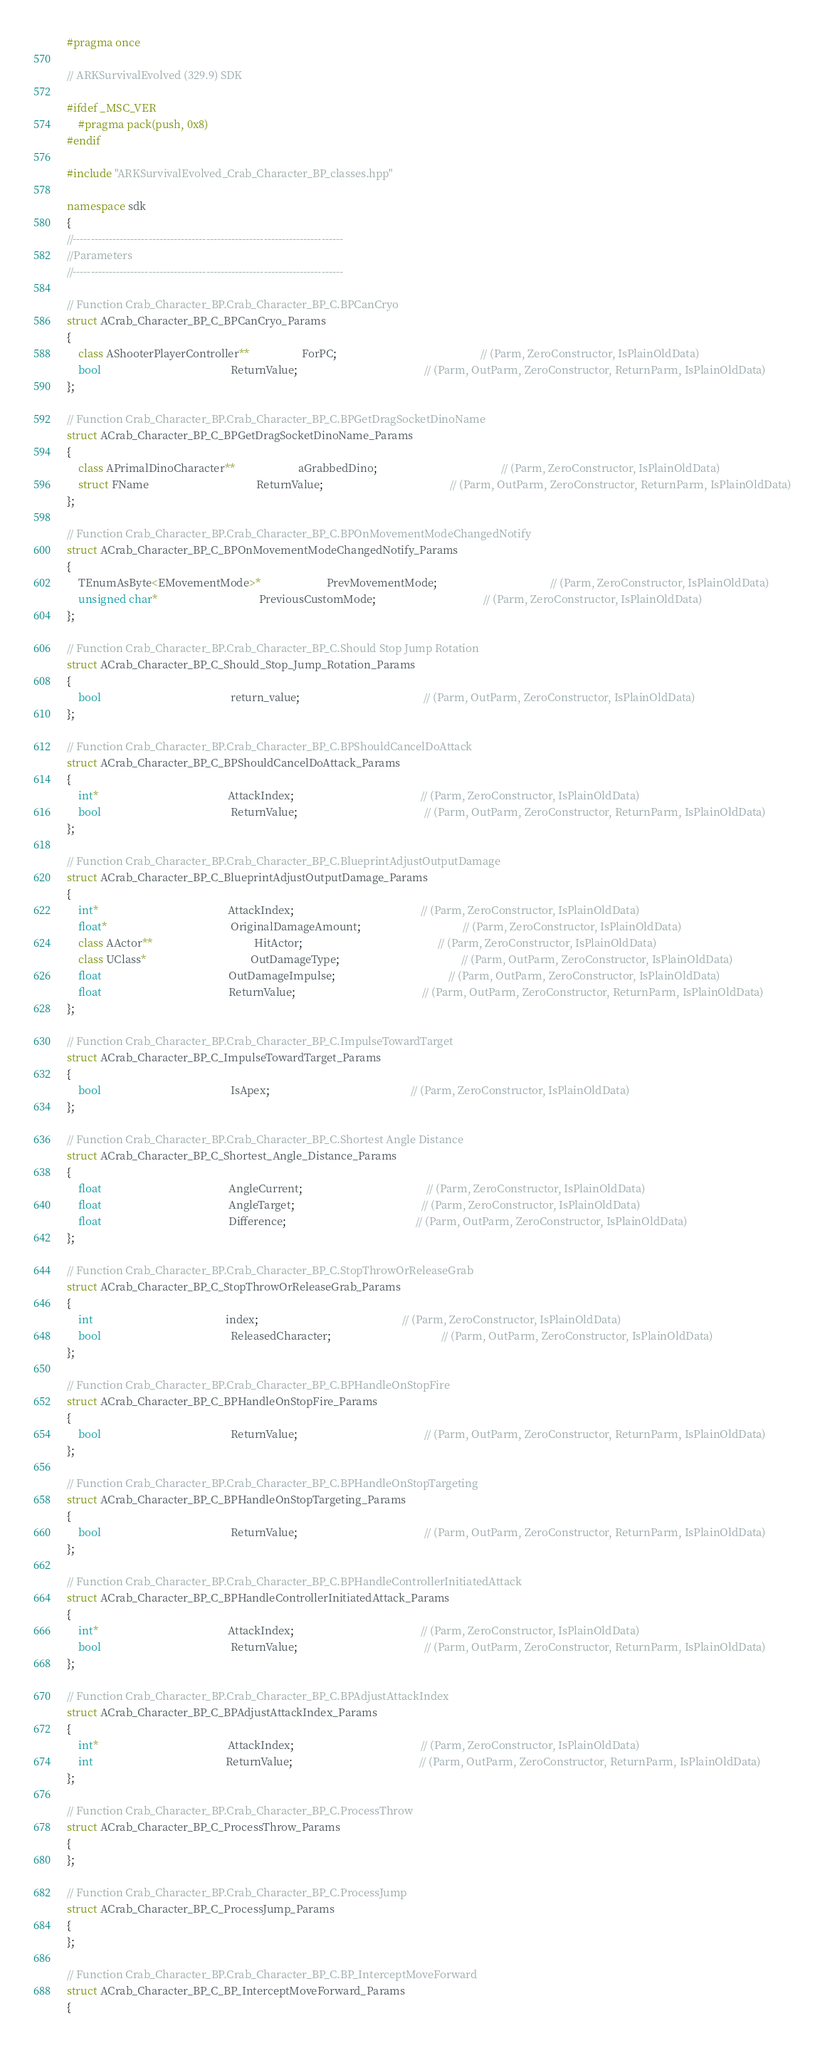<code> <loc_0><loc_0><loc_500><loc_500><_C++_>#pragma once

// ARKSurvivalEvolved (329.9) SDK

#ifdef _MSC_VER
	#pragma pack(push, 0x8)
#endif

#include "ARKSurvivalEvolved_Crab_Character_BP_classes.hpp"

namespace sdk
{
//---------------------------------------------------------------------------
//Parameters
//---------------------------------------------------------------------------

// Function Crab_Character_BP.Crab_Character_BP_C.BPCanCryo
struct ACrab_Character_BP_C_BPCanCryo_Params
{
	class AShooterPlayerController**                   ForPC;                                                    // (Parm, ZeroConstructor, IsPlainOldData)
	bool                                               ReturnValue;                                              // (Parm, OutParm, ZeroConstructor, ReturnParm, IsPlainOldData)
};

// Function Crab_Character_BP.Crab_Character_BP_C.BPGetDragSocketDinoName
struct ACrab_Character_BP_C_BPGetDragSocketDinoName_Params
{
	class APrimalDinoCharacter**                       aGrabbedDino;                                             // (Parm, ZeroConstructor, IsPlainOldData)
	struct FName                                       ReturnValue;                                              // (Parm, OutParm, ZeroConstructor, ReturnParm, IsPlainOldData)
};

// Function Crab_Character_BP.Crab_Character_BP_C.BPOnMovementModeChangedNotify
struct ACrab_Character_BP_C_BPOnMovementModeChangedNotify_Params
{
	TEnumAsByte<EMovementMode>*                        PrevMovementMode;                                         // (Parm, ZeroConstructor, IsPlainOldData)
	unsigned char*                                     PreviousCustomMode;                                       // (Parm, ZeroConstructor, IsPlainOldData)
};

// Function Crab_Character_BP.Crab_Character_BP_C.Should Stop Jump Rotation
struct ACrab_Character_BP_C_Should_Stop_Jump_Rotation_Params
{
	bool                                               return_value;                                             // (Parm, OutParm, ZeroConstructor, IsPlainOldData)
};

// Function Crab_Character_BP.Crab_Character_BP_C.BPShouldCancelDoAttack
struct ACrab_Character_BP_C_BPShouldCancelDoAttack_Params
{
	int*                                               AttackIndex;                                              // (Parm, ZeroConstructor, IsPlainOldData)
	bool                                               ReturnValue;                                              // (Parm, OutParm, ZeroConstructor, ReturnParm, IsPlainOldData)
};

// Function Crab_Character_BP.Crab_Character_BP_C.BlueprintAdjustOutputDamage
struct ACrab_Character_BP_C_BlueprintAdjustOutputDamage_Params
{
	int*                                               AttackIndex;                                              // (Parm, ZeroConstructor, IsPlainOldData)
	float*                                             OriginalDamageAmount;                                     // (Parm, ZeroConstructor, IsPlainOldData)
	class AActor**                                     HitActor;                                                 // (Parm, ZeroConstructor, IsPlainOldData)
	class UClass*                                      OutDamageType;                                            // (Parm, OutParm, ZeroConstructor, IsPlainOldData)
	float                                              OutDamageImpulse;                                         // (Parm, OutParm, ZeroConstructor, IsPlainOldData)
	float                                              ReturnValue;                                              // (Parm, OutParm, ZeroConstructor, ReturnParm, IsPlainOldData)
};

// Function Crab_Character_BP.Crab_Character_BP_C.ImpulseTowardTarget
struct ACrab_Character_BP_C_ImpulseTowardTarget_Params
{
	bool                                               IsApex;                                                   // (Parm, ZeroConstructor, IsPlainOldData)
};

// Function Crab_Character_BP.Crab_Character_BP_C.Shortest Angle Distance
struct ACrab_Character_BP_C_Shortest_Angle_Distance_Params
{
	float                                              AngleCurrent;                                             // (Parm, ZeroConstructor, IsPlainOldData)
	float                                              AngleTarget;                                              // (Parm, ZeroConstructor, IsPlainOldData)
	float                                              Difference;                                               // (Parm, OutParm, ZeroConstructor, IsPlainOldData)
};

// Function Crab_Character_BP.Crab_Character_BP_C.StopThrowOrReleaseGrab
struct ACrab_Character_BP_C_StopThrowOrReleaseGrab_Params
{
	int                                                index;                                                    // (Parm, ZeroConstructor, IsPlainOldData)
	bool                                               ReleasedCharacter;                                        // (Parm, OutParm, ZeroConstructor, IsPlainOldData)
};

// Function Crab_Character_BP.Crab_Character_BP_C.BPHandleOnStopFire
struct ACrab_Character_BP_C_BPHandleOnStopFire_Params
{
	bool                                               ReturnValue;                                              // (Parm, OutParm, ZeroConstructor, ReturnParm, IsPlainOldData)
};

// Function Crab_Character_BP.Crab_Character_BP_C.BPHandleOnStopTargeting
struct ACrab_Character_BP_C_BPHandleOnStopTargeting_Params
{
	bool                                               ReturnValue;                                              // (Parm, OutParm, ZeroConstructor, ReturnParm, IsPlainOldData)
};

// Function Crab_Character_BP.Crab_Character_BP_C.BPHandleControllerInitiatedAttack
struct ACrab_Character_BP_C_BPHandleControllerInitiatedAttack_Params
{
	int*                                               AttackIndex;                                              // (Parm, ZeroConstructor, IsPlainOldData)
	bool                                               ReturnValue;                                              // (Parm, OutParm, ZeroConstructor, ReturnParm, IsPlainOldData)
};

// Function Crab_Character_BP.Crab_Character_BP_C.BPAdjustAttackIndex
struct ACrab_Character_BP_C_BPAdjustAttackIndex_Params
{
	int*                                               AttackIndex;                                              // (Parm, ZeroConstructor, IsPlainOldData)
	int                                                ReturnValue;                                              // (Parm, OutParm, ZeroConstructor, ReturnParm, IsPlainOldData)
};

// Function Crab_Character_BP.Crab_Character_BP_C.ProcessThrow
struct ACrab_Character_BP_C_ProcessThrow_Params
{
};

// Function Crab_Character_BP.Crab_Character_BP_C.ProcessJump
struct ACrab_Character_BP_C_ProcessJump_Params
{
};

// Function Crab_Character_BP.Crab_Character_BP_C.BP_InterceptMoveForward
struct ACrab_Character_BP_C_BP_InterceptMoveForward_Params
{</code> 